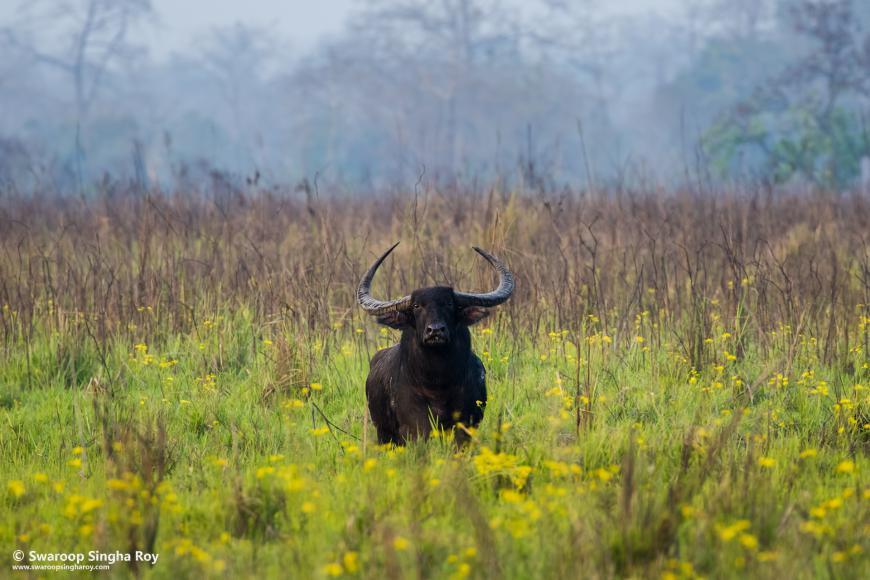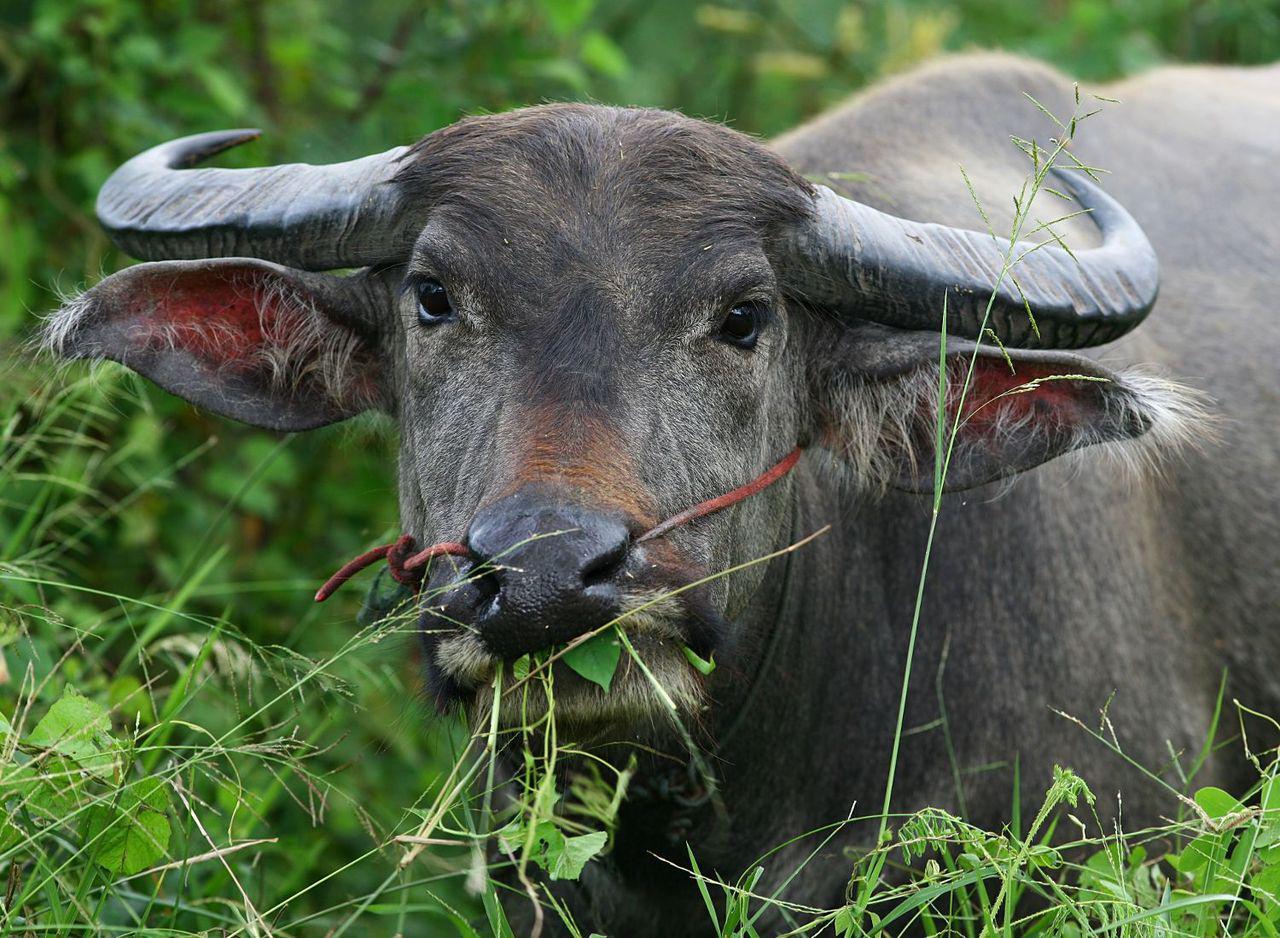The first image is the image on the left, the second image is the image on the right. Assess this claim about the two images: "there is at least on animal standing on a path". Correct or not? Answer yes or no. No. The first image is the image on the left, the second image is the image on the right. Considering the images on both sides, is "The left image contains one water buffalo looking directly at the camera, and the right image includes a water bufflao with a cord threaded through its nose." valid? Answer yes or no. Yes. 